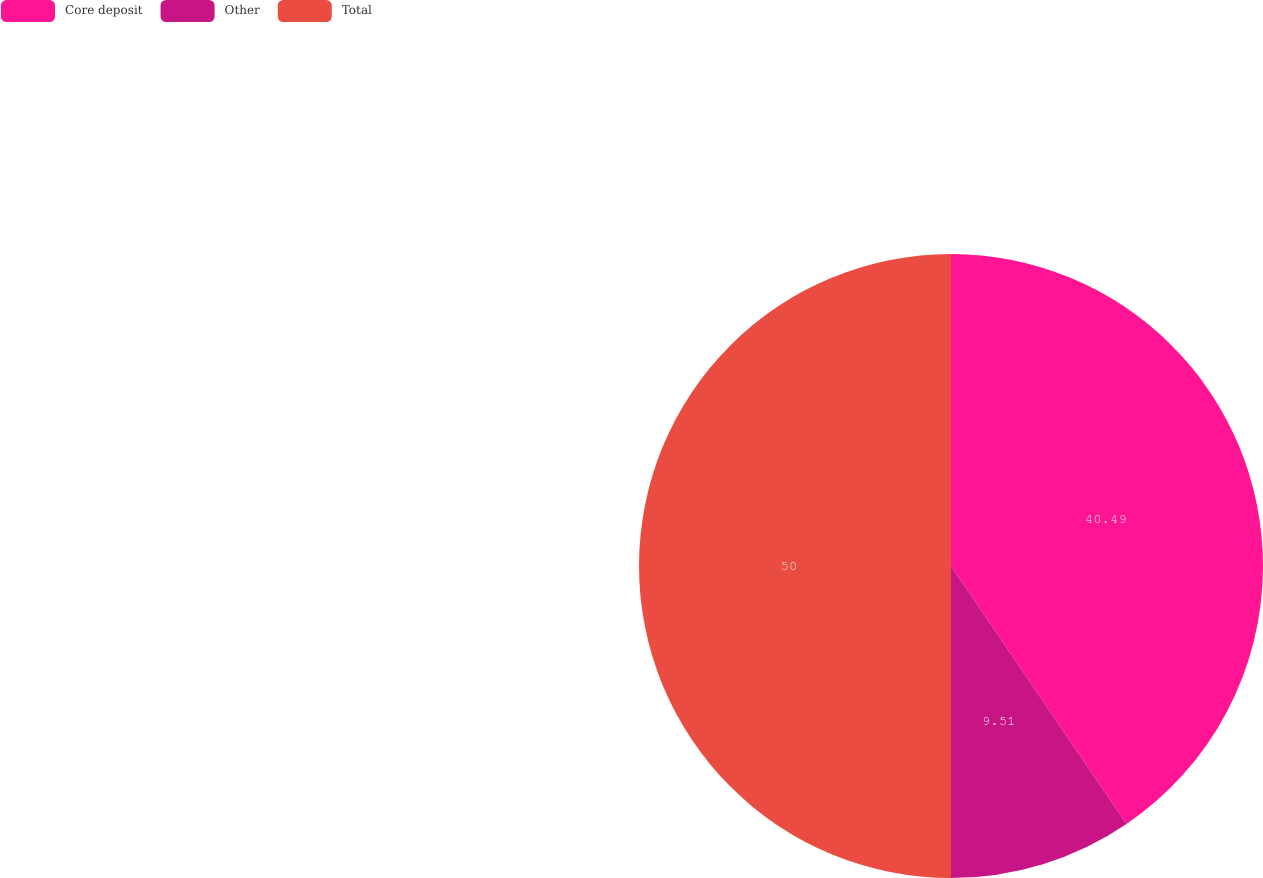Convert chart. <chart><loc_0><loc_0><loc_500><loc_500><pie_chart><fcel>Core deposit<fcel>Other<fcel>Total<nl><fcel>40.49%<fcel>9.51%<fcel>50.0%<nl></chart> 